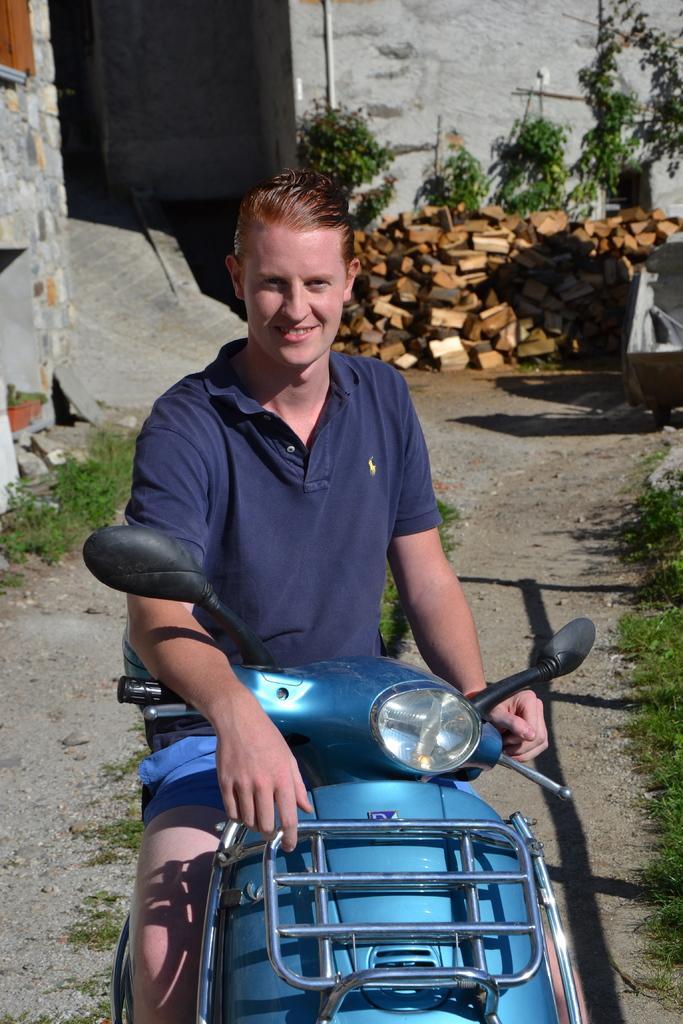Can you describe this image briefly? In this image we can see a man sitting on the motor vehicle. In the background we can see plants, wooden blocks, grass and walls. 